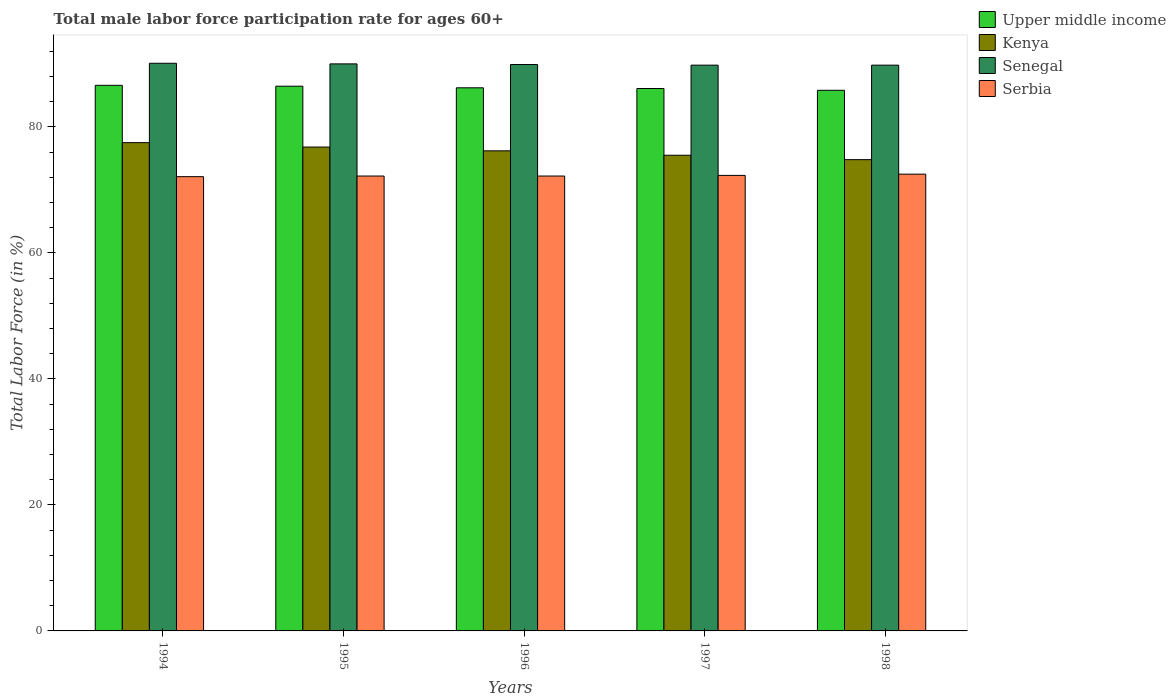Are the number of bars per tick equal to the number of legend labels?
Give a very brief answer. Yes. Are the number of bars on each tick of the X-axis equal?
Your response must be concise. Yes. How many bars are there on the 2nd tick from the right?
Offer a terse response. 4. What is the male labor force participation rate in Kenya in 1994?
Your answer should be very brief. 77.5. Across all years, what is the maximum male labor force participation rate in Senegal?
Give a very brief answer. 90.1. Across all years, what is the minimum male labor force participation rate in Kenya?
Your response must be concise. 74.8. What is the total male labor force participation rate in Kenya in the graph?
Provide a succinct answer. 380.8. What is the difference between the male labor force participation rate in Serbia in 1997 and that in 1998?
Ensure brevity in your answer.  -0.2. What is the difference between the male labor force participation rate in Upper middle income in 1996 and the male labor force participation rate in Serbia in 1995?
Ensure brevity in your answer.  14. What is the average male labor force participation rate in Senegal per year?
Make the answer very short. 89.92. In the year 1997, what is the difference between the male labor force participation rate in Upper middle income and male labor force participation rate in Kenya?
Your answer should be compact. 10.59. What is the ratio of the male labor force participation rate in Serbia in 1994 to that in 1996?
Provide a succinct answer. 1. Is the difference between the male labor force participation rate in Upper middle income in 1995 and 1998 greater than the difference between the male labor force participation rate in Kenya in 1995 and 1998?
Your response must be concise. No. What is the difference between the highest and the second highest male labor force participation rate in Serbia?
Provide a succinct answer. 0.2. What is the difference between the highest and the lowest male labor force participation rate in Upper middle income?
Your answer should be compact. 0.79. In how many years, is the male labor force participation rate in Senegal greater than the average male labor force participation rate in Senegal taken over all years?
Your answer should be very brief. 2. Is the sum of the male labor force participation rate in Upper middle income in 1994 and 1998 greater than the maximum male labor force participation rate in Senegal across all years?
Your response must be concise. Yes. Is it the case that in every year, the sum of the male labor force participation rate in Senegal and male labor force participation rate in Kenya is greater than the sum of male labor force participation rate in Upper middle income and male labor force participation rate in Serbia?
Make the answer very short. Yes. What does the 4th bar from the left in 1998 represents?
Provide a short and direct response. Serbia. What does the 4th bar from the right in 1996 represents?
Give a very brief answer. Upper middle income. How many years are there in the graph?
Ensure brevity in your answer.  5. What is the difference between two consecutive major ticks on the Y-axis?
Your answer should be compact. 20. Are the values on the major ticks of Y-axis written in scientific E-notation?
Keep it short and to the point. No. Does the graph contain any zero values?
Your response must be concise. No. Does the graph contain grids?
Your answer should be compact. No. How many legend labels are there?
Your answer should be compact. 4. How are the legend labels stacked?
Give a very brief answer. Vertical. What is the title of the graph?
Your response must be concise. Total male labor force participation rate for ages 60+. What is the label or title of the Y-axis?
Ensure brevity in your answer.  Total Labor Force (in %). What is the Total Labor Force (in %) in Upper middle income in 1994?
Give a very brief answer. 86.6. What is the Total Labor Force (in %) in Kenya in 1994?
Give a very brief answer. 77.5. What is the Total Labor Force (in %) of Senegal in 1994?
Your response must be concise. 90.1. What is the Total Labor Force (in %) of Serbia in 1994?
Offer a terse response. 72.1. What is the Total Labor Force (in %) of Upper middle income in 1995?
Keep it short and to the point. 86.46. What is the Total Labor Force (in %) in Kenya in 1995?
Make the answer very short. 76.8. What is the Total Labor Force (in %) in Serbia in 1995?
Your answer should be very brief. 72.2. What is the Total Labor Force (in %) of Upper middle income in 1996?
Your response must be concise. 86.2. What is the Total Labor Force (in %) of Kenya in 1996?
Your answer should be compact. 76.2. What is the Total Labor Force (in %) in Senegal in 1996?
Keep it short and to the point. 89.9. What is the Total Labor Force (in %) of Serbia in 1996?
Keep it short and to the point. 72.2. What is the Total Labor Force (in %) of Upper middle income in 1997?
Your answer should be compact. 86.09. What is the Total Labor Force (in %) of Kenya in 1997?
Make the answer very short. 75.5. What is the Total Labor Force (in %) of Senegal in 1997?
Ensure brevity in your answer.  89.8. What is the Total Labor Force (in %) in Serbia in 1997?
Offer a very short reply. 72.3. What is the Total Labor Force (in %) of Upper middle income in 1998?
Provide a succinct answer. 85.81. What is the Total Labor Force (in %) in Kenya in 1998?
Make the answer very short. 74.8. What is the Total Labor Force (in %) in Senegal in 1998?
Give a very brief answer. 89.8. What is the Total Labor Force (in %) of Serbia in 1998?
Your answer should be compact. 72.5. Across all years, what is the maximum Total Labor Force (in %) of Upper middle income?
Your response must be concise. 86.6. Across all years, what is the maximum Total Labor Force (in %) in Kenya?
Your answer should be compact. 77.5. Across all years, what is the maximum Total Labor Force (in %) in Senegal?
Give a very brief answer. 90.1. Across all years, what is the maximum Total Labor Force (in %) of Serbia?
Offer a very short reply. 72.5. Across all years, what is the minimum Total Labor Force (in %) in Upper middle income?
Offer a terse response. 85.81. Across all years, what is the minimum Total Labor Force (in %) in Kenya?
Provide a short and direct response. 74.8. Across all years, what is the minimum Total Labor Force (in %) of Senegal?
Keep it short and to the point. 89.8. Across all years, what is the minimum Total Labor Force (in %) of Serbia?
Offer a terse response. 72.1. What is the total Total Labor Force (in %) in Upper middle income in the graph?
Make the answer very short. 431.16. What is the total Total Labor Force (in %) of Kenya in the graph?
Offer a very short reply. 380.8. What is the total Total Labor Force (in %) of Senegal in the graph?
Your answer should be very brief. 449.6. What is the total Total Labor Force (in %) in Serbia in the graph?
Keep it short and to the point. 361.3. What is the difference between the Total Labor Force (in %) in Upper middle income in 1994 and that in 1995?
Your answer should be compact. 0.14. What is the difference between the Total Labor Force (in %) of Serbia in 1994 and that in 1995?
Offer a very short reply. -0.1. What is the difference between the Total Labor Force (in %) of Upper middle income in 1994 and that in 1996?
Your answer should be very brief. 0.4. What is the difference between the Total Labor Force (in %) in Senegal in 1994 and that in 1996?
Ensure brevity in your answer.  0.2. What is the difference between the Total Labor Force (in %) of Serbia in 1994 and that in 1996?
Provide a short and direct response. -0.1. What is the difference between the Total Labor Force (in %) of Upper middle income in 1994 and that in 1997?
Offer a terse response. 0.51. What is the difference between the Total Labor Force (in %) of Kenya in 1994 and that in 1997?
Your answer should be compact. 2. What is the difference between the Total Labor Force (in %) of Upper middle income in 1994 and that in 1998?
Your answer should be very brief. 0.79. What is the difference between the Total Labor Force (in %) of Kenya in 1994 and that in 1998?
Keep it short and to the point. 2.7. What is the difference between the Total Labor Force (in %) in Senegal in 1994 and that in 1998?
Offer a very short reply. 0.3. What is the difference between the Total Labor Force (in %) in Serbia in 1994 and that in 1998?
Your answer should be very brief. -0.4. What is the difference between the Total Labor Force (in %) of Upper middle income in 1995 and that in 1996?
Offer a very short reply. 0.26. What is the difference between the Total Labor Force (in %) of Kenya in 1995 and that in 1996?
Offer a very short reply. 0.6. What is the difference between the Total Labor Force (in %) of Senegal in 1995 and that in 1996?
Offer a very short reply. 0.1. What is the difference between the Total Labor Force (in %) in Upper middle income in 1995 and that in 1997?
Your answer should be compact. 0.37. What is the difference between the Total Labor Force (in %) in Senegal in 1995 and that in 1997?
Your answer should be compact. 0.2. What is the difference between the Total Labor Force (in %) of Upper middle income in 1995 and that in 1998?
Offer a very short reply. 0.65. What is the difference between the Total Labor Force (in %) of Kenya in 1995 and that in 1998?
Keep it short and to the point. 2. What is the difference between the Total Labor Force (in %) in Senegal in 1995 and that in 1998?
Keep it short and to the point. 0.2. What is the difference between the Total Labor Force (in %) in Upper middle income in 1996 and that in 1997?
Give a very brief answer. 0.11. What is the difference between the Total Labor Force (in %) of Kenya in 1996 and that in 1997?
Your answer should be compact. 0.7. What is the difference between the Total Labor Force (in %) in Serbia in 1996 and that in 1997?
Offer a very short reply. -0.1. What is the difference between the Total Labor Force (in %) of Upper middle income in 1996 and that in 1998?
Make the answer very short. 0.4. What is the difference between the Total Labor Force (in %) of Senegal in 1996 and that in 1998?
Ensure brevity in your answer.  0.1. What is the difference between the Total Labor Force (in %) of Serbia in 1996 and that in 1998?
Provide a succinct answer. -0.3. What is the difference between the Total Labor Force (in %) in Upper middle income in 1997 and that in 1998?
Give a very brief answer. 0.29. What is the difference between the Total Labor Force (in %) in Senegal in 1997 and that in 1998?
Your answer should be very brief. 0. What is the difference between the Total Labor Force (in %) of Serbia in 1997 and that in 1998?
Your answer should be very brief. -0.2. What is the difference between the Total Labor Force (in %) of Upper middle income in 1994 and the Total Labor Force (in %) of Kenya in 1995?
Offer a terse response. 9.8. What is the difference between the Total Labor Force (in %) of Upper middle income in 1994 and the Total Labor Force (in %) of Senegal in 1995?
Offer a terse response. -3.4. What is the difference between the Total Labor Force (in %) in Upper middle income in 1994 and the Total Labor Force (in %) in Serbia in 1995?
Ensure brevity in your answer.  14.4. What is the difference between the Total Labor Force (in %) in Senegal in 1994 and the Total Labor Force (in %) in Serbia in 1995?
Provide a short and direct response. 17.9. What is the difference between the Total Labor Force (in %) of Upper middle income in 1994 and the Total Labor Force (in %) of Kenya in 1996?
Offer a very short reply. 10.4. What is the difference between the Total Labor Force (in %) in Upper middle income in 1994 and the Total Labor Force (in %) in Senegal in 1996?
Give a very brief answer. -3.3. What is the difference between the Total Labor Force (in %) in Upper middle income in 1994 and the Total Labor Force (in %) in Serbia in 1996?
Your answer should be compact. 14.4. What is the difference between the Total Labor Force (in %) of Kenya in 1994 and the Total Labor Force (in %) of Serbia in 1996?
Offer a very short reply. 5.3. What is the difference between the Total Labor Force (in %) in Upper middle income in 1994 and the Total Labor Force (in %) in Kenya in 1997?
Provide a short and direct response. 11.1. What is the difference between the Total Labor Force (in %) in Upper middle income in 1994 and the Total Labor Force (in %) in Senegal in 1997?
Your response must be concise. -3.2. What is the difference between the Total Labor Force (in %) in Upper middle income in 1994 and the Total Labor Force (in %) in Serbia in 1997?
Your response must be concise. 14.3. What is the difference between the Total Labor Force (in %) in Kenya in 1994 and the Total Labor Force (in %) in Senegal in 1997?
Keep it short and to the point. -12.3. What is the difference between the Total Labor Force (in %) in Senegal in 1994 and the Total Labor Force (in %) in Serbia in 1997?
Your answer should be compact. 17.8. What is the difference between the Total Labor Force (in %) in Upper middle income in 1994 and the Total Labor Force (in %) in Kenya in 1998?
Keep it short and to the point. 11.8. What is the difference between the Total Labor Force (in %) of Upper middle income in 1994 and the Total Labor Force (in %) of Senegal in 1998?
Offer a very short reply. -3.2. What is the difference between the Total Labor Force (in %) of Upper middle income in 1994 and the Total Labor Force (in %) of Serbia in 1998?
Your answer should be compact. 14.1. What is the difference between the Total Labor Force (in %) of Kenya in 1994 and the Total Labor Force (in %) of Senegal in 1998?
Your answer should be very brief. -12.3. What is the difference between the Total Labor Force (in %) in Upper middle income in 1995 and the Total Labor Force (in %) in Kenya in 1996?
Ensure brevity in your answer.  10.26. What is the difference between the Total Labor Force (in %) of Upper middle income in 1995 and the Total Labor Force (in %) of Senegal in 1996?
Offer a terse response. -3.44. What is the difference between the Total Labor Force (in %) in Upper middle income in 1995 and the Total Labor Force (in %) in Serbia in 1996?
Your answer should be very brief. 14.26. What is the difference between the Total Labor Force (in %) in Kenya in 1995 and the Total Labor Force (in %) in Senegal in 1996?
Your answer should be very brief. -13.1. What is the difference between the Total Labor Force (in %) of Senegal in 1995 and the Total Labor Force (in %) of Serbia in 1996?
Make the answer very short. 17.8. What is the difference between the Total Labor Force (in %) in Upper middle income in 1995 and the Total Labor Force (in %) in Kenya in 1997?
Offer a very short reply. 10.96. What is the difference between the Total Labor Force (in %) in Upper middle income in 1995 and the Total Labor Force (in %) in Senegal in 1997?
Keep it short and to the point. -3.34. What is the difference between the Total Labor Force (in %) of Upper middle income in 1995 and the Total Labor Force (in %) of Serbia in 1997?
Offer a very short reply. 14.16. What is the difference between the Total Labor Force (in %) of Kenya in 1995 and the Total Labor Force (in %) of Senegal in 1997?
Make the answer very short. -13. What is the difference between the Total Labor Force (in %) of Senegal in 1995 and the Total Labor Force (in %) of Serbia in 1997?
Ensure brevity in your answer.  17.7. What is the difference between the Total Labor Force (in %) of Upper middle income in 1995 and the Total Labor Force (in %) of Kenya in 1998?
Your response must be concise. 11.66. What is the difference between the Total Labor Force (in %) in Upper middle income in 1995 and the Total Labor Force (in %) in Senegal in 1998?
Offer a terse response. -3.34. What is the difference between the Total Labor Force (in %) in Upper middle income in 1995 and the Total Labor Force (in %) in Serbia in 1998?
Your answer should be compact. 13.96. What is the difference between the Total Labor Force (in %) in Senegal in 1995 and the Total Labor Force (in %) in Serbia in 1998?
Your answer should be very brief. 17.5. What is the difference between the Total Labor Force (in %) of Upper middle income in 1996 and the Total Labor Force (in %) of Kenya in 1997?
Your answer should be very brief. 10.7. What is the difference between the Total Labor Force (in %) in Upper middle income in 1996 and the Total Labor Force (in %) in Senegal in 1997?
Your answer should be very brief. -3.6. What is the difference between the Total Labor Force (in %) of Upper middle income in 1996 and the Total Labor Force (in %) of Serbia in 1997?
Your response must be concise. 13.9. What is the difference between the Total Labor Force (in %) of Kenya in 1996 and the Total Labor Force (in %) of Senegal in 1997?
Your answer should be compact. -13.6. What is the difference between the Total Labor Force (in %) of Kenya in 1996 and the Total Labor Force (in %) of Serbia in 1997?
Provide a succinct answer. 3.9. What is the difference between the Total Labor Force (in %) of Upper middle income in 1996 and the Total Labor Force (in %) of Kenya in 1998?
Offer a terse response. 11.4. What is the difference between the Total Labor Force (in %) in Upper middle income in 1996 and the Total Labor Force (in %) in Senegal in 1998?
Give a very brief answer. -3.6. What is the difference between the Total Labor Force (in %) in Upper middle income in 1996 and the Total Labor Force (in %) in Serbia in 1998?
Provide a succinct answer. 13.7. What is the difference between the Total Labor Force (in %) of Upper middle income in 1997 and the Total Labor Force (in %) of Kenya in 1998?
Your answer should be very brief. 11.29. What is the difference between the Total Labor Force (in %) of Upper middle income in 1997 and the Total Labor Force (in %) of Senegal in 1998?
Ensure brevity in your answer.  -3.71. What is the difference between the Total Labor Force (in %) in Upper middle income in 1997 and the Total Labor Force (in %) in Serbia in 1998?
Make the answer very short. 13.59. What is the difference between the Total Labor Force (in %) of Kenya in 1997 and the Total Labor Force (in %) of Senegal in 1998?
Keep it short and to the point. -14.3. What is the difference between the Total Labor Force (in %) in Kenya in 1997 and the Total Labor Force (in %) in Serbia in 1998?
Offer a very short reply. 3. What is the difference between the Total Labor Force (in %) in Senegal in 1997 and the Total Labor Force (in %) in Serbia in 1998?
Keep it short and to the point. 17.3. What is the average Total Labor Force (in %) in Upper middle income per year?
Your response must be concise. 86.23. What is the average Total Labor Force (in %) in Kenya per year?
Make the answer very short. 76.16. What is the average Total Labor Force (in %) of Senegal per year?
Provide a succinct answer. 89.92. What is the average Total Labor Force (in %) in Serbia per year?
Make the answer very short. 72.26. In the year 1994, what is the difference between the Total Labor Force (in %) of Upper middle income and Total Labor Force (in %) of Kenya?
Provide a succinct answer. 9.1. In the year 1994, what is the difference between the Total Labor Force (in %) of Upper middle income and Total Labor Force (in %) of Senegal?
Make the answer very short. -3.5. In the year 1994, what is the difference between the Total Labor Force (in %) in Upper middle income and Total Labor Force (in %) in Serbia?
Your answer should be compact. 14.5. In the year 1994, what is the difference between the Total Labor Force (in %) of Kenya and Total Labor Force (in %) of Senegal?
Keep it short and to the point. -12.6. In the year 1994, what is the difference between the Total Labor Force (in %) in Kenya and Total Labor Force (in %) in Serbia?
Offer a very short reply. 5.4. In the year 1994, what is the difference between the Total Labor Force (in %) in Senegal and Total Labor Force (in %) in Serbia?
Your answer should be compact. 18. In the year 1995, what is the difference between the Total Labor Force (in %) of Upper middle income and Total Labor Force (in %) of Kenya?
Your answer should be compact. 9.66. In the year 1995, what is the difference between the Total Labor Force (in %) in Upper middle income and Total Labor Force (in %) in Senegal?
Provide a succinct answer. -3.54. In the year 1995, what is the difference between the Total Labor Force (in %) in Upper middle income and Total Labor Force (in %) in Serbia?
Offer a terse response. 14.26. In the year 1996, what is the difference between the Total Labor Force (in %) of Upper middle income and Total Labor Force (in %) of Kenya?
Keep it short and to the point. 10. In the year 1996, what is the difference between the Total Labor Force (in %) of Upper middle income and Total Labor Force (in %) of Senegal?
Provide a succinct answer. -3.7. In the year 1996, what is the difference between the Total Labor Force (in %) of Upper middle income and Total Labor Force (in %) of Serbia?
Ensure brevity in your answer.  14. In the year 1996, what is the difference between the Total Labor Force (in %) of Kenya and Total Labor Force (in %) of Senegal?
Offer a terse response. -13.7. In the year 1997, what is the difference between the Total Labor Force (in %) in Upper middle income and Total Labor Force (in %) in Kenya?
Your response must be concise. 10.59. In the year 1997, what is the difference between the Total Labor Force (in %) of Upper middle income and Total Labor Force (in %) of Senegal?
Your answer should be compact. -3.71. In the year 1997, what is the difference between the Total Labor Force (in %) of Upper middle income and Total Labor Force (in %) of Serbia?
Your answer should be compact. 13.79. In the year 1997, what is the difference between the Total Labor Force (in %) of Kenya and Total Labor Force (in %) of Senegal?
Provide a short and direct response. -14.3. In the year 1998, what is the difference between the Total Labor Force (in %) of Upper middle income and Total Labor Force (in %) of Kenya?
Provide a short and direct response. 11.01. In the year 1998, what is the difference between the Total Labor Force (in %) of Upper middle income and Total Labor Force (in %) of Senegal?
Provide a short and direct response. -3.99. In the year 1998, what is the difference between the Total Labor Force (in %) of Upper middle income and Total Labor Force (in %) of Serbia?
Your response must be concise. 13.31. In the year 1998, what is the difference between the Total Labor Force (in %) of Kenya and Total Labor Force (in %) of Senegal?
Your response must be concise. -15. In the year 1998, what is the difference between the Total Labor Force (in %) of Senegal and Total Labor Force (in %) of Serbia?
Give a very brief answer. 17.3. What is the ratio of the Total Labor Force (in %) of Upper middle income in 1994 to that in 1995?
Offer a very short reply. 1. What is the ratio of the Total Labor Force (in %) of Kenya in 1994 to that in 1995?
Make the answer very short. 1.01. What is the ratio of the Total Labor Force (in %) in Kenya in 1994 to that in 1996?
Give a very brief answer. 1.02. What is the ratio of the Total Labor Force (in %) in Senegal in 1994 to that in 1996?
Provide a short and direct response. 1. What is the ratio of the Total Labor Force (in %) of Upper middle income in 1994 to that in 1997?
Ensure brevity in your answer.  1.01. What is the ratio of the Total Labor Force (in %) of Kenya in 1994 to that in 1997?
Your answer should be compact. 1.03. What is the ratio of the Total Labor Force (in %) in Senegal in 1994 to that in 1997?
Offer a terse response. 1. What is the ratio of the Total Labor Force (in %) in Upper middle income in 1994 to that in 1998?
Offer a terse response. 1.01. What is the ratio of the Total Labor Force (in %) of Kenya in 1994 to that in 1998?
Your answer should be compact. 1.04. What is the ratio of the Total Labor Force (in %) of Senegal in 1994 to that in 1998?
Offer a terse response. 1. What is the ratio of the Total Labor Force (in %) in Serbia in 1994 to that in 1998?
Keep it short and to the point. 0.99. What is the ratio of the Total Labor Force (in %) of Kenya in 1995 to that in 1996?
Offer a very short reply. 1.01. What is the ratio of the Total Labor Force (in %) in Senegal in 1995 to that in 1996?
Offer a very short reply. 1. What is the ratio of the Total Labor Force (in %) in Upper middle income in 1995 to that in 1997?
Your answer should be compact. 1. What is the ratio of the Total Labor Force (in %) of Kenya in 1995 to that in 1997?
Offer a very short reply. 1.02. What is the ratio of the Total Labor Force (in %) in Serbia in 1995 to that in 1997?
Offer a very short reply. 1. What is the ratio of the Total Labor Force (in %) of Upper middle income in 1995 to that in 1998?
Ensure brevity in your answer.  1.01. What is the ratio of the Total Labor Force (in %) of Kenya in 1995 to that in 1998?
Provide a short and direct response. 1.03. What is the ratio of the Total Labor Force (in %) of Senegal in 1995 to that in 1998?
Keep it short and to the point. 1. What is the ratio of the Total Labor Force (in %) of Upper middle income in 1996 to that in 1997?
Provide a succinct answer. 1. What is the ratio of the Total Labor Force (in %) of Kenya in 1996 to that in 1997?
Give a very brief answer. 1.01. What is the ratio of the Total Labor Force (in %) of Senegal in 1996 to that in 1997?
Your response must be concise. 1. What is the ratio of the Total Labor Force (in %) in Serbia in 1996 to that in 1997?
Provide a short and direct response. 1. What is the ratio of the Total Labor Force (in %) in Kenya in 1996 to that in 1998?
Offer a very short reply. 1.02. What is the ratio of the Total Labor Force (in %) in Senegal in 1996 to that in 1998?
Provide a succinct answer. 1. What is the ratio of the Total Labor Force (in %) in Serbia in 1996 to that in 1998?
Offer a very short reply. 1. What is the ratio of the Total Labor Force (in %) in Upper middle income in 1997 to that in 1998?
Ensure brevity in your answer.  1. What is the ratio of the Total Labor Force (in %) in Kenya in 1997 to that in 1998?
Give a very brief answer. 1.01. What is the ratio of the Total Labor Force (in %) of Senegal in 1997 to that in 1998?
Provide a succinct answer. 1. What is the difference between the highest and the second highest Total Labor Force (in %) of Upper middle income?
Make the answer very short. 0.14. What is the difference between the highest and the second highest Total Labor Force (in %) in Serbia?
Your answer should be compact. 0.2. What is the difference between the highest and the lowest Total Labor Force (in %) of Upper middle income?
Offer a very short reply. 0.79. What is the difference between the highest and the lowest Total Labor Force (in %) in Kenya?
Provide a succinct answer. 2.7. 